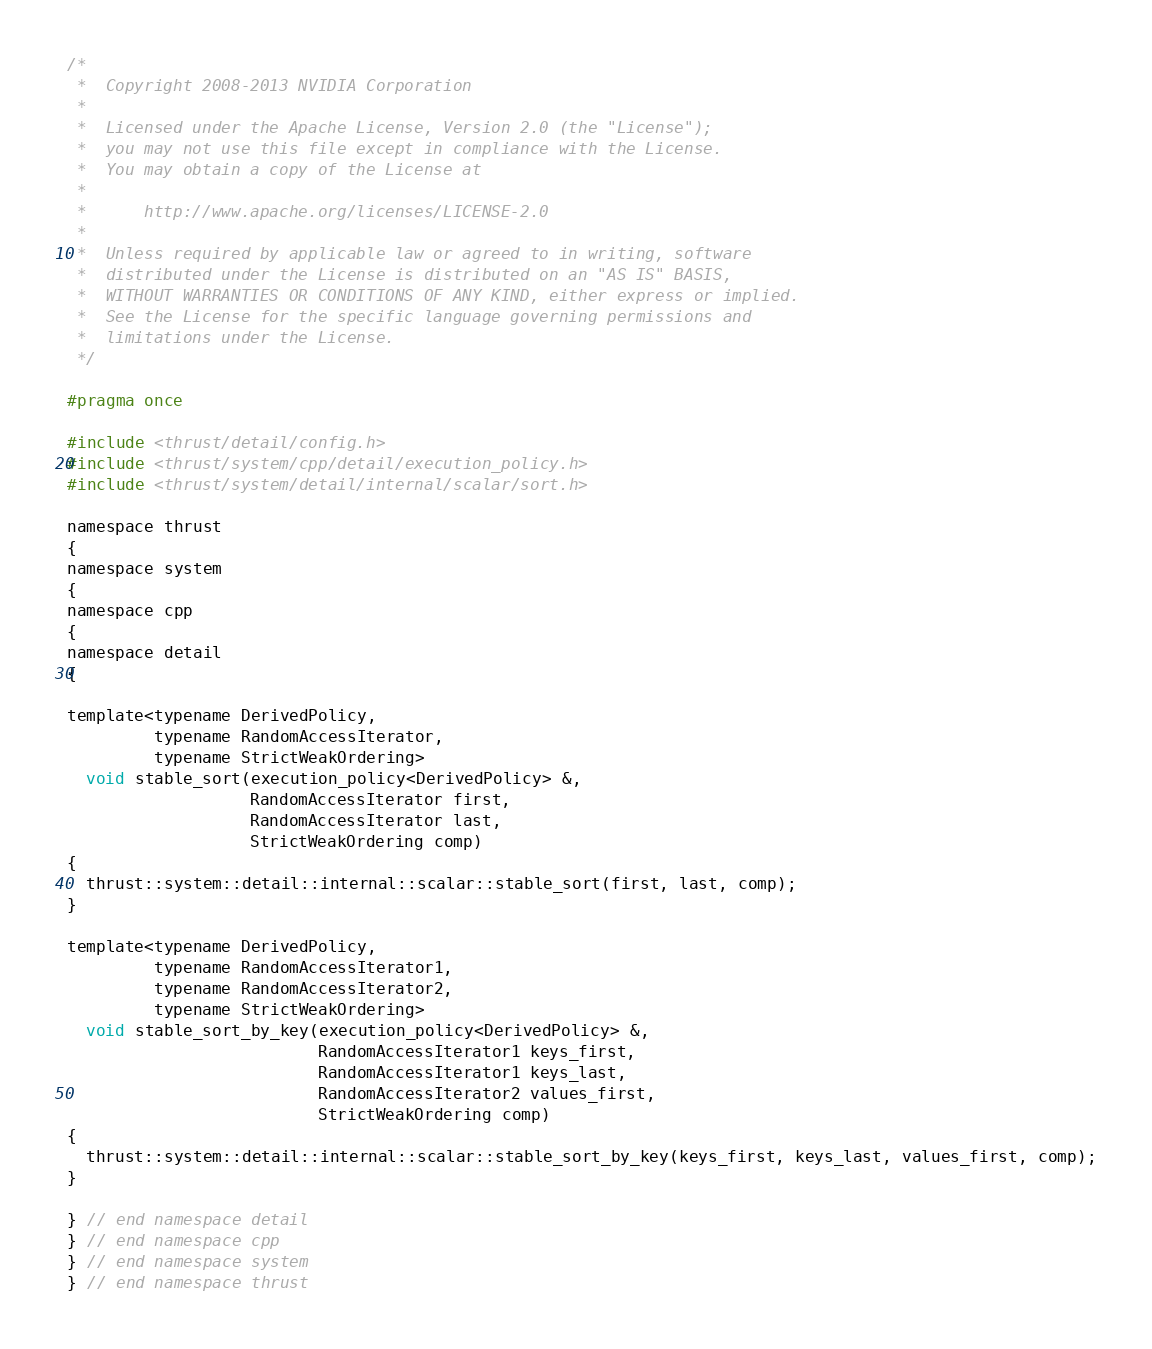<code> <loc_0><loc_0><loc_500><loc_500><_C_>/*
 *  Copyright 2008-2013 NVIDIA Corporation
 *
 *  Licensed under the Apache License, Version 2.0 (the "License");
 *  you may not use this file except in compliance with the License.
 *  You may obtain a copy of the License at
 *
 *      http://www.apache.org/licenses/LICENSE-2.0
 *
 *  Unless required by applicable law or agreed to in writing, software
 *  distributed under the License is distributed on an "AS IS" BASIS,
 *  WITHOUT WARRANTIES OR CONDITIONS OF ANY KIND, either express or implied.
 *  See the License for the specific language governing permissions and
 *  limitations under the License.
 */

#pragma once

#include <thrust/detail/config.h>
#include <thrust/system/cpp/detail/execution_policy.h>
#include <thrust/system/detail/internal/scalar/sort.h>

namespace thrust
{
namespace system
{
namespace cpp
{
namespace detail
{

template<typename DerivedPolicy,
         typename RandomAccessIterator,
         typename StrictWeakOrdering>
  void stable_sort(execution_policy<DerivedPolicy> &,
                   RandomAccessIterator first,
                   RandomAccessIterator last,
                   StrictWeakOrdering comp)
{
  thrust::system::detail::internal::scalar::stable_sort(first, last, comp);
}

template<typename DerivedPolicy,
         typename RandomAccessIterator1,
         typename RandomAccessIterator2,
         typename StrictWeakOrdering>
  void stable_sort_by_key(execution_policy<DerivedPolicy> &,
                          RandomAccessIterator1 keys_first,
                          RandomAccessIterator1 keys_last,
                          RandomAccessIterator2 values_first,
                          StrictWeakOrdering comp)
{
  thrust::system::detail::internal::scalar::stable_sort_by_key(keys_first, keys_last, values_first, comp);
}

} // end namespace detail
} // end namespace cpp
} // end namespace system
} // end namespace thrust

</code> 